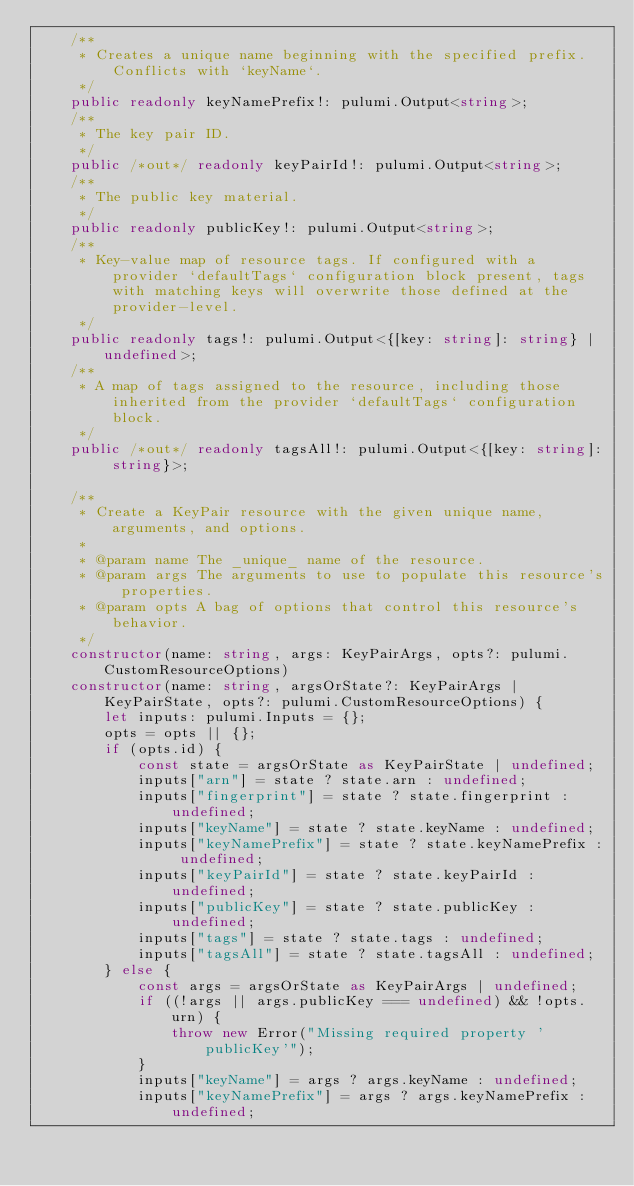<code> <loc_0><loc_0><loc_500><loc_500><_TypeScript_>    /**
     * Creates a unique name beginning with the specified prefix. Conflicts with `keyName`.
     */
    public readonly keyNamePrefix!: pulumi.Output<string>;
    /**
     * The key pair ID.
     */
    public /*out*/ readonly keyPairId!: pulumi.Output<string>;
    /**
     * The public key material.
     */
    public readonly publicKey!: pulumi.Output<string>;
    /**
     * Key-value map of resource tags. If configured with a provider `defaultTags` configuration block present, tags with matching keys will overwrite those defined at the provider-level.
     */
    public readonly tags!: pulumi.Output<{[key: string]: string} | undefined>;
    /**
     * A map of tags assigned to the resource, including those inherited from the provider `defaultTags` configuration block.
     */
    public /*out*/ readonly tagsAll!: pulumi.Output<{[key: string]: string}>;

    /**
     * Create a KeyPair resource with the given unique name, arguments, and options.
     *
     * @param name The _unique_ name of the resource.
     * @param args The arguments to use to populate this resource's properties.
     * @param opts A bag of options that control this resource's behavior.
     */
    constructor(name: string, args: KeyPairArgs, opts?: pulumi.CustomResourceOptions)
    constructor(name: string, argsOrState?: KeyPairArgs | KeyPairState, opts?: pulumi.CustomResourceOptions) {
        let inputs: pulumi.Inputs = {};
        opts = opts || {};
        if (opts.id) {
            const state = argsOrState as KeyPairState | undefined;
            inputs["arn"] = state ? state.arn : undefined;
            inputs["fingerprint"] = state ? state.fingerprint : undefined;
            inputs["keyName"] = state ? state.keyName : undefined;
            inputs["keyNamePrefix"] = state ? state.keyNamePrefix : undefined;
            inputs["keyPairId"] = state ? state.keyPairId : undefined;
            inputs["publicKey"] = state ? state.publicKey : undefined;
            inputs["tags"] = state ? state.tags : undefined;
            inputs["tagsAll"] = state ? state.tagsAll : undefined;
        } else {
            const args = argsOrState as KeyPairArgs | undefined;
            if ((!args || args.publicKey === undefined) && !opts.urn) {
                throw new Error("Missing required property 'publicKey'");
            }
            inputs["keyName"] = args ? args.keyName : undefined;
            inputs["keyNamePrefix"] = args ? args.keyNamePrefix : undefined;</code> 